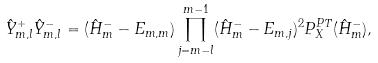Convert formula to latex. <formula><loc_0><loc_0><loc_500><loc_500>\hat { Y } _ { m , l } ^ { + } \hat { Y } _ { m , l } ^ { - } = ( \hat { H } ^ { - } _ { m } - E _ { m , m } ) \prod _ { j = m - l } ^ { m - 1 } ( \hat { H } ^ { - } _ { m } - E _ { m , j } ) ^ { 2 } P ^ { P T } _ { X } ( \hat { H } ^ { - } _ { m } ) ,</formula> 